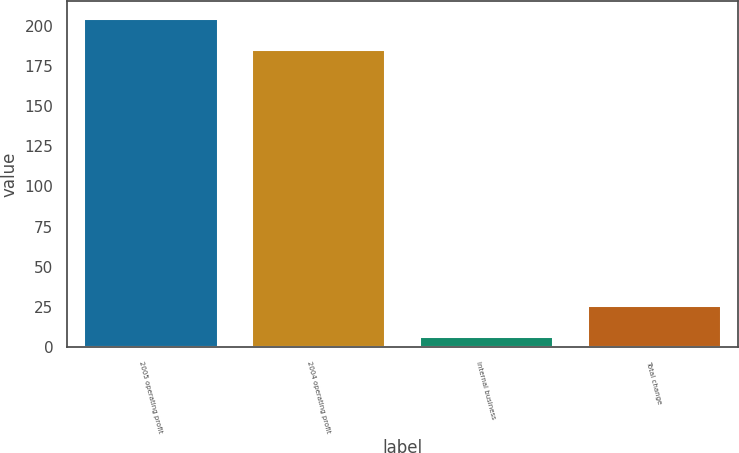<chart> <loc_0><loc_0><loc_500><loc_500><bar_chart><fcel>2005 operating profit<fcel>2004 operating profit<fcel>Internal business<fcel>Total change<nl><fcel>205.02<fcel>185.4<fcel>6.6<fcel>26.22<nl></chart> 